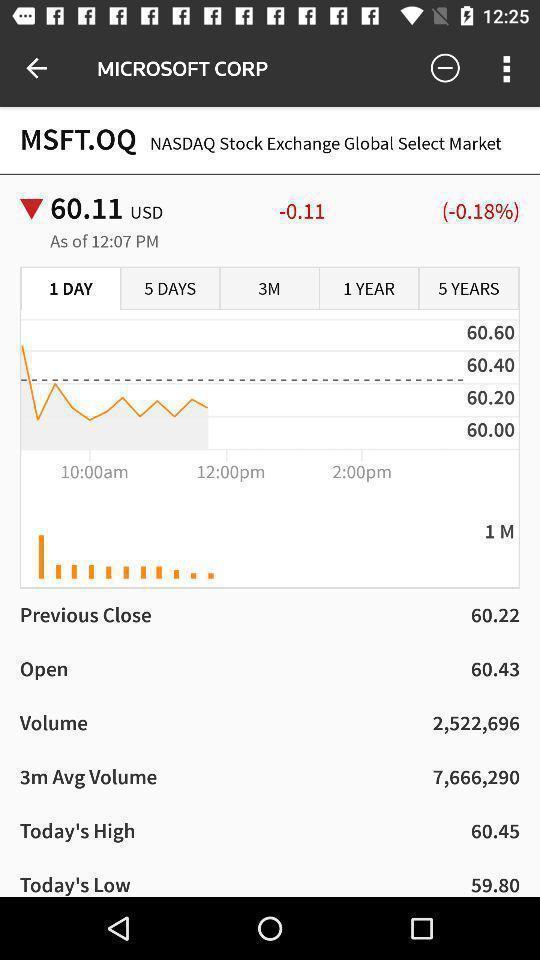Describe this image in words. Page showing stock value in financial app. 